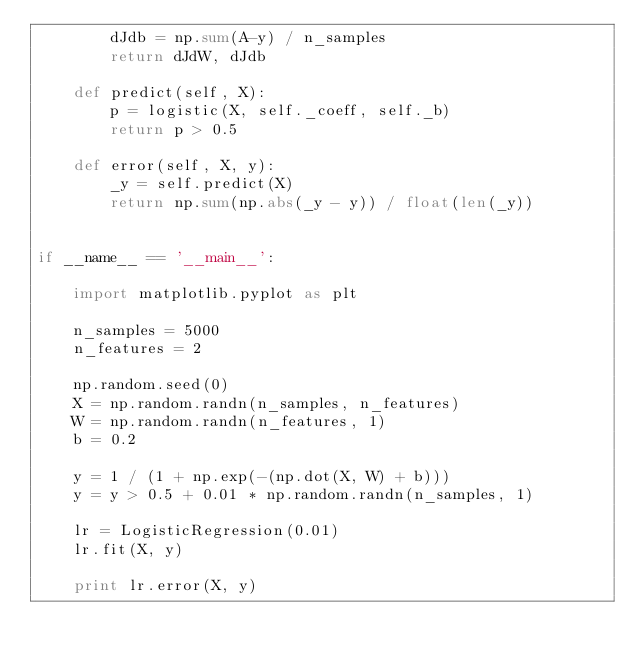Convert code to text. <code><loc_0><loc_0><loc_500><loc_500><_Python_>        dJdb = np.sum(A-y) / n_samples
        return dJdW, dJdb

    def predict(self, X):
        p = logistic(X, self._coeff, self._b)
        return p > 0.5

    def error(self, X, y):
        _y = self.predict(X)
        return np.sum(np.abs(_y - y)) / float(len(_y))


if __name__ == '__main__':

    import matplotlib.pyplot as plt

    n_samples = 5000
    n_features = 2

    np.random.seed(0)
    X = np.random.randn(n_samples, n_features)
    W = np.random.randn(n_features, 1)
    b = 0.2

    y = 1 / (1 + np.exp(-(np.dot(X, W) + b)))
    y = y > 0.5 + 0.01 * np.random.randn(n_samples, 1)

    lr = LogisticRegression(0.01)
    lr.fit(X, y)

    print lr.error(X, y)
</code> 